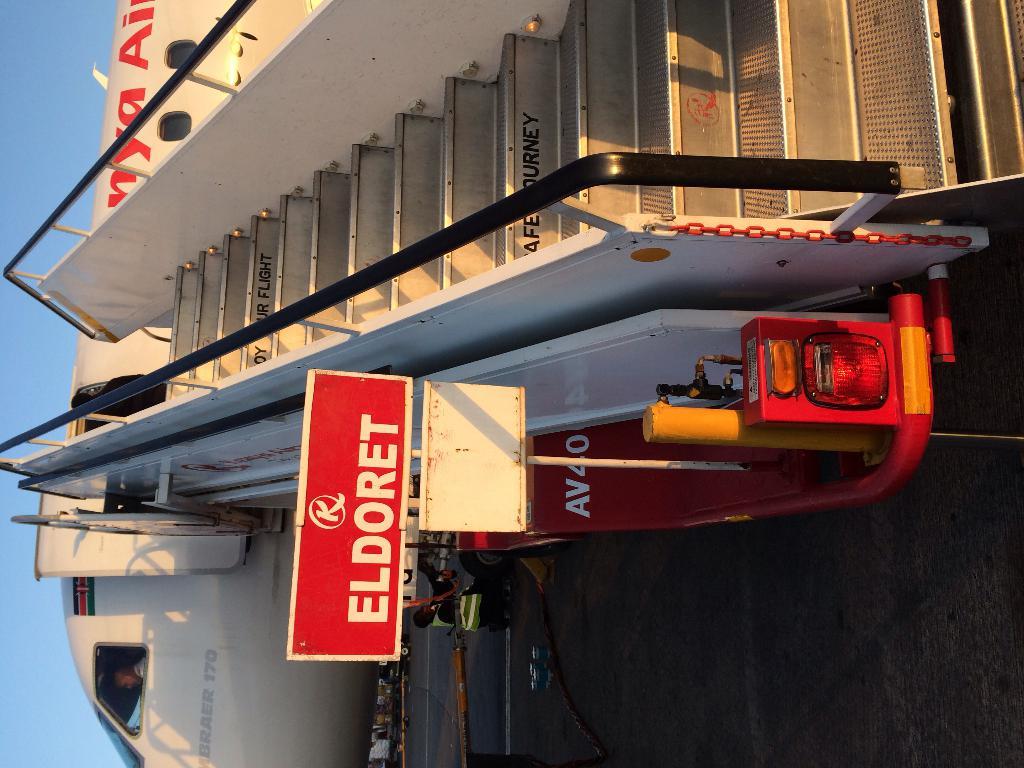The fourth stair from the top implores one to enjoy their what?
Make the answer very short. Flight. What does the red sign say?
Ensure brevity in your answer.  Eldoret. 